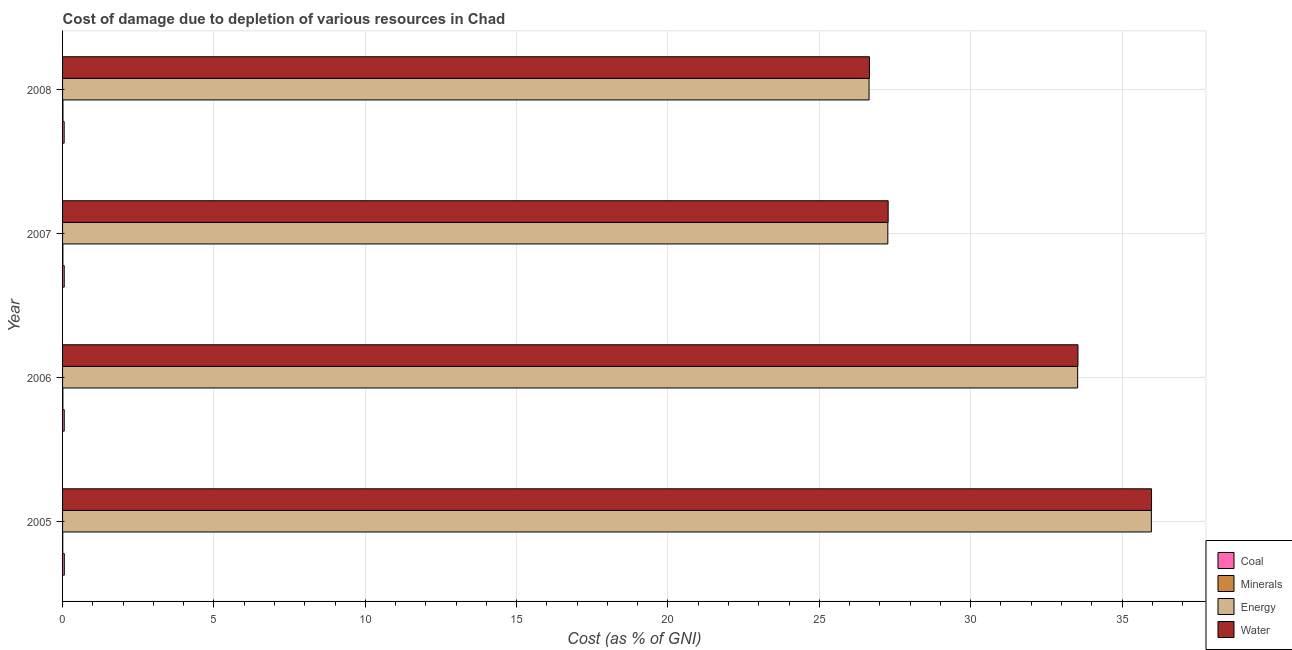Are the number of bars per tick equal to the number of legend labels?
Keep it short and to the point. Yes. Are the number of bars on each tick of the Y-axis equal?
Ensure brevity in your answer.  Yes. How many bars are there on the 1st tick from the top?
Provide a short and direct response. 4. How many bars are there on the 4th tick from the bottom?
Keep it short and to the point. 4. What is the label of the 1st group of bars from the top?
Give a very brief answer. 2008. In how many cases, is the number of bars for a given year not equal to the number of legend labels?
Your response must be concise. 0. What is the cost of damage due to depletion of energy in 2005?
Provide a short and direct response. 35.97. Across all years, what is the maximum cost of damage due to depletion of energy?
Ensure brevity in your answer.  35.97. Across all years, what is the minimum cost of damage due to depletion of energy?
Your response must be concise. 26.64. In which year was the cost of damage due to depletion of minerals maximum?
Offer a terse response. 2008. In which year was the cost of damage due to depletion of minerals minimum?
Make the answer very short. 2005. What is the total cost of damage due to depletion of coal in the graph?
Keep it short and to the point. 0.22. What is the difference between the cost of damage due to depletion of energy in 2006 and that in 2008?
Offer a very short reply. 6.89. What is the difference between the cost of damage due to depletion of minerals in 2008 and the cost of damage due to depletion of water in 2006?
Your answer should be very brief. -33.53. What is the average cost of damage due to depletion of coal per year?
Provide a succinct answer. 0.06. In the year 2005, what is the difference between the cost of damage due to depletion of energy and cost of damage due to depletion of minerals?
Offer a very short reply. 35.96. What is the ratio of the cost of damage due to depletion of coal in 2006 to that in 2007?
Offer a very short reply. 1.02. Is the difference between the cost of damage due to depletion of water in 2006 and 2008 greater than the difference between the cost of damage due to depletion of coal in 2006 and 2008?
Offer a very short reply. Yes. What is the difference between the highest and the second highest cost of damage due to depletion of minerals?
Ensure brevity in your answer.  0. What is the difference between the highest and the lowest cost of damage due to depletion of minerals?
Give a very brief answer. 0.01. In how many years, is the cost of damage due to depletion of coal greater than the average cost of damage due to depletion of coal taken over all years?
Offer a terse response. 2. What does the 2nd bar from the top in 2006 represents?
Your response must be concise. Energy. What does the 2nd bar from the bottom in 2006 represents?
Your answer should be compact. Minerals. Is it the case that in every year, the sum of the cost of damage due to depletion of coal and cost of damage due to depletion of minerals is greater than the cost of damage due to depletion of energy?
Make the answer very short. No. What is the difference between two consecutive major ticks on the X-axis?
Offer a terse response. 5. Does the graph contain any zero values?
Provide a short and direct response. No. Where does the legend appear in the graph?
Your answer should be compact. Bottom right. How are the legend labels stacked?
Your answer should be compact. Vertical. What is the title of the graph?
Your response must be concise. Cost of damage due to depletion of various resources in Chad . What is the label or title of the X-axis?
Ensure brevity in your answer.  Cost (as % of GNI). What is the Cost (as % of GNI) of Coal in 2005?
Provide a succinct answer. 0.06. What is the Cost (as % of GNI) in Minerals in 2005?
Provide a short and direct response. 0.01. What is the Cost (as % of GNI) of Energy in 2005?
Your response must be concise. 35.97. What is the Cost (as % of GNI) in Water in 2005?
Your response must be concise. 35.98. What is the Cost (as % of GNI) of Coal in 2006?
Give a very brief answer. 0.06. What is the Cost (as % of GNI) of Minerals in 2006?
Offer a terse response. 0.01. What is the Cost (as % of GNI) in Energy in 2006?
Give a very brief answer. 33.53. What is the Cost (as % of GNI) in Water in 2006?
Provide a succinct answer. 33.54. What is the Cost (as % of GNI) in Coal in 2007?
Offer a very short reply. 0.05. What is the Cost (as % of GNI) in Minerals in 2007?
Offer a terse response. 0.01. What is the Cost (as % of GNI) of Energy in 2007?
Your answer should be very brief. 27.26. What is the Cost (as % of GNI) of Water in 2007?
Your response must be concise. 27.27. What is the Cost (as % of GNI) in Coal in 2008?
Provide a succinct answer. 0.05. What is the Cost (as % of GNI) of Minerals in 2008?
Your answer should be compact. 0.01. What is the Cost (as % of GNI) of Energy in 2008?
Provide a short and direct response. 26.64. What is the Cost (as % of GNI) in Water in 2008?
Your answer should be very brief. 26.66. Across all years, what is the maximum Cost (as % of GNI) in Coal?
Offer a terse response. 0.06. Across all years, what is the maximum Cost (as % of GNI) in Minerals?
Provide a succinct answer. 0.01. Across all years, what is the maximum Cost (as % of GNI) in Energy?
Keep it short and to the point. 35.97. Across all years, what is the maximum Cost (as % of GNI) of Water?
Ensure brevity in your answer.  35.98. Across all years, what is the minimum Cost (as % of GNI) in Coal?
Provide a succinct answer. 0.05. Across all years, what is the minimum Cost (as % of GNI) of Minerals?
Give a very brief answer. 0.01. Across all years, what is the minimum Cost (as % of GNI) in Energy?
Keep it short and to the point. 26.64. Across all years, what is the minimum Cost (as % of GNI) of Water?
Offer a terse response. 26.66. What is the total Cost (as % of GNI) of Coal in the graph?
Offer a terse response. 0.22. What is the total Cost (as % of GNI) of Minerals in the graph?
Your answer should be very brief. 0.04. What is the total Cost (as % of GNI) in Energy in the graph?
Offer a terse response. 123.41. What is the total Cost (as % of GNI) in Water in the graph?
Keep it short and to the point. 123.45. What is the difference between the Cost (as % of GNI) of Coal in 2005 and that in 2006?
Make the answer very short. 0. What is the difference between the Cost (as % of GNI) in Minerals in 2005 and that in 2006?
Offer a very short reply. -0. What is the difference between the Cost (as % of GNI) of Energy in 2005 and that in 2006?
Your answer should be very brief. 2.43. What is the difference between the Cost (as % of GNI) in Water in 2005 and that in 2006?
Offer a very short reply. 2.43. What is the difference between the Cost (as % of GNI) of Coal in 2005 and that in 2007?
Ensure brevity in your answer.  0. What is the difference between the Cost (as % of GNI) in Minerals in 2005 and that in 2007?
Your answer should be very brief. -0.01. What is the difference between the Cost (as % of GNI) of Energy in 2005 and that in 2007?
Offer a very short reply. 8.71. What is the difference between the Cost (as % of GNI) in Water in 2005 and that in 2007?
Your answer should be compact. 8.7. What is the difference between the Cost (as % of GNI) in Coal in 2005 and that in 2008?
Give a very brief answer. 0. What is the difference between the Cost (as % of GNI) of Minerals in 2005 and that in 2008?
Offer a very short reply. -0.01. What is the difference between the Cost (as % of GNI) of Energy in 2005 and that in 2008?
Offer a terse response. 9.33. What is the difference between the Cost (as % of GNI) of Water in 2005 and that in 2008?
Offer a terse response. 9.32. What is the difference between the Cost (as % of GNI) of Coal in 2006 and that in 2007?
Your response must be concise. 0. What is the difference between the Cost (as % of GNI) in Minerals in 2006 and that in 2007?
Make the answer very short. -0. What is the difference between the Cost (as % of GNI) in Energy in 2006 and that in 2007?
Offer a terse response. 6.27. What is the difference between the Cost (as % of GNI) of Water in 2006 and that in 2007?
Ensure brevity in your answer.  6.27. What is the difference between the Cost (as % of GNI) of Coal in 2006 and that in 2008?
Make the answer very short. 0. What is the difference between the Cost (as % of GNI) of Minerals in 2006 and that in 2008?
Your response must be concise. -0. What is the difference between the Cost (as % of GNI) of Energy in 2006 and that in 2008?
Give a very brief answer. 6.89. What is the difference between the Cost (as % of GNI) of Water in 2006 and that in 2008?
Provide a succinct answer. 6.89. What is the difference between the Cost (as % of GNI) in Coal in 2007 and that in 2008?
Your answer should be very brief. 0. What is the difference between the Cost (as % of GNI) in Minerals in 2007 and that in 2008?
Offer a terse response. -0. What is the difference between the Cost (as % of GNI) of Energy in 2007 and that in 2008?
Your response must be concise. 0.62. What is the difference between the Cost (as % of GNI) of Water in 2007 and that in 2008?
Keep it short and to the point. 0.62. What is the difference between the Cost (as % of GNI) of Coal in 2005 and the Cost (as % of GNI) of Minerals in 2006?
Provide a succinct answer. 0.05. What is the difference between the Cost (as % of GNI) in Coal in 2005 and the Cost (as % of GNI) in Energy in 2006?
Offer a terse response. -33.48. What is the difference between the Cost (as % of GNI) in Coal in 2005 and the Cost (as % of GNI) in Water in 2006?
Provide a succinct answer. -33.49. What is the difference between the Cost (as % of GNI) of Minerals in 2005 and the Cost (as % of GNI) of Energy in 2006?
Give a very brief answer. -33.53. What is the difference between the Cost (as % of GNI) of Minerals in 2005 and the Cost (as % of GNI) of Water in 2006?
Give a very brief answer. -33.54. What is the difference between the Cost (as % of GNI) of Energy in 2005 and the Cost (as % of GNI) of Water in 2006?
Your answer should be very brief. 2.42. What is the difference between the Cost (as % of GNI) in Coal in 2005 and the Cost (as % of GNI) in Minerals in 2007?
Offer a terse response. 0.05. What is the difference between the Cost (as % of GNI) in Coal in 2005 and the Cost (as % of GNI) in Energy in 2007?
Provide a succinct answer. -27.21. What is the difference between the Cost (as % of GNI) in Coal in 2005 and the Cost (as % of GNI) in Water in 2007?
Your answer should be very brief. -27.22. What is the difference between the Cost (as % of GNI) of Minerals in 2005 and the Cost (as % of GNI) of Energy in 2007?
Offer a very short reply. -27.26. What is the difference between the Cost (as % of GNI) of Minerals in 2005 and the Cost (as % of GNI) of Water in 2007?
Provide a succinct answer. -27.27. What is the difference between the Cost (as % of GNI) of Energy in 2005 and the Cost (as % of GNI) of Water in 2007?
Your response must be concise. 8.7. What is the difference between the Cost (as % of GNI) of Coal in 2005 and the Cost (as % of GNI) of Minerals in 2008?
Offer a terse response. 0.04. What is the difference between the Cost (as % of GNI) in Coal in 2005 and the Cost (as % of GNI) in Energy in 2008?
Provide a succinct answer. -26.59. What is the difference between the Cost (as % of GNI) of Coal in 2005 and the Cost (as % of GNI) of Water in 2008?
Your answer should be very brief. -26.6. What is the difference between the Cost (as % of GNI) in Minerals in 2005 and the Cost (as % of GNI) in Energy in 2008?
Ensure brevity in your answer.  -26.64. What is the difference between the Cost (as % of GNI) of Minerals in 2005 and the Cost (as % of GNI) of Water in 2008?
Make the answer very short. -26.65. What is the difference between the Cost (as % of GNI) of Energy in 2005 and the Cost (as % of GNI) of Water in 2008?
Offer a very short reply. 9.31. What is the difference between the Cost (as % of GNI) of Coal in 2006 and the Cost (as % of GNI) of Minerals in 2007?
Offer a very short reply. 0.04. What is the difference between the Cost (as % of GNI) in Coal in 2006 and the Cost (as % of GNI) in Energy in 2007?
Offer a very short reply. -27.21. What is the difference between the Cost (as % of GNI) of Coal in 2006 and the Cost (as % of GNI) of Water in 2007?
Provide a short and direct response. -27.22. What is the difference between the Cost (as % of GNI) of Minerals in 2006 and the Cost (as % of GNI) of Energy in 2007?
Make the answer very short. -27.25. What is the difference between the Cost (as % of GNI) of Minerals in 2006 and the Cost (as % of GNI) of Water in 2007?
Offer a terse response. -27.26. What is the difference between the Cost (as % of GNI) of Energy in 2006 and the Cost (as % of GNI) of Water in 2007?
Provide a short and direct response. 6.26. What is the difference between the Cost (as % of GNI) in Coal in 2006 and the Cost (as % of GNI) in Minerals in 2008?
Provide a succinct answer. 0.04. What is the difference between the Cost (as % of GNI) of Coal in 2006 and the Cost (as % of GNI) of Energy in 2008?
Offer a very short reply. -26.59. What is the difference between the Cost (as % of GNI) of Coal in 2006 and the Cost (as % of GNI) of Water in 2008?
Offer a terse response. -26.6. What is the difference between the Cost (as % of GNI) of Minerals in 2006 and the Cost (as % of GNI) of Energy in 2008?
Provide a short and direct response. -26.63. What is the difference between the Cost (as % of GNI) of Minerals in 2006 and the Cost (as % of GNI) of Water in 2008?
Your answer should be very brief. -26.65. What is the difference between the Cost (as % of GNI) in Energy in 2006 and the Cost (as % of GNI) in Water in 2008?
Your answer should be compact. 6.88. What is the difference between the Cost (as % of GNI) in Coal in 2007 and the Cost (as % of GNI) in Minerals in 2008?
Offer a terse response. 0.04. What is the difference between the Cost (as % of GNI) in Coal in 2007 and the Cost (as % of GNI) in Energy in 2008?
Your response must be concise. -26.59. What is the difference between the Cost (as % of GNI) in Coal in 2007 and the Cost (as % of GNI) in Water in 2008?
Your answer should be very brief. -26.6. What is the difference between the Cost (as % of GNI) of Minerals in 2007 and the Cost (as % of GNI) of Energy in 2008?
Offer a terse response. -26.63. What is the difference between the Cost (as % of GNI) in Minerals in 2007 and the Cost (as % of GNI) in Water in 2008?
Your response must be concise. -26.65. What is the difference between the Cost (as % of GNI) in Energy in 2007 and the Cost (as % of GNI) in Water in 2008?
Ensure brevity in your answer.  0.61. What is the average Cost (as % of GNI) in Coal per year?
Your response must be concise. 0.06. What is the average Cost (as % of GNI) in Minerals per year?
Make the answer very short. 0.01. What is the average Cost (as % of GNI) in Energy per year?
Your answer should be very brief. 30.85. What is the average Cost (as % of GNI) in Water per year?
Ensure brevity in your answer.  30.86. In the year 2005, what is the difference between the Cost (as % of GNI) in Coal and Cost (as % of GNI) in Minerals?
Offer a terse response. 0.05. In the year 2005, what is the difference between the Cost (as % of GNI) of Coal and Cost (as % of GNI) of Energy?
Keep it short and to the point. -35.91. In the year 2005, what is the difference between the Cost (as % of GNI) of Coal and Cost (as % of GNI) of Water?
Your response must be concise. -35.92. In the year 2005, what is the difference between the Cost (as % of GNI) of Minerals and Cost (as % of GNI) of Energy?
Provide a short and direct response. -35.96. In the year 2005, what is the difference between the Cost (as % of GNI) of Minerals and Cost (as % of GNI) of Water?
Make the answer very short. -35.97. In the year 2005, what is the difference between the Cost (as % of GNI) in Energy and Cost (as % of GNI) in Water?
Make the answer very short. -0.01. In the year 2006, what is the difference between the Cost (as % of GNI) in Coal and Cost (as % of GNI) in Minerals?
Your answer should be compact. 0.05. In the year 2006, what is the difference between the Cost (as % of GNI) in Coal and Cost (as % of GNI) in Energy?
Keep it short and to the point. -33.48. In the year 2006, what is the difference between the Cost (as % of GNI) in Coal and Cost (as % of GNI) in Water?
Ensure brevity in your answer.  -33.49. In the year 2006, what is the difference between the Cost (as % of GNI) of Minerals and Cost (as % of GNI) of Energy?
Your response must be concise. -33.52. In the year 2006, what is the difference between the Cost (as % of GNI) of Minerals and Cost (as % of GNI) of Water?
Offer a terse response. -33.53. In the year 2006, what is the difference between the Cost (as % of GNI) of Energy and Cost (as % of GNI) of Water?
Ensure brevity in your answer.  -0.01. In the year 2007, what is the difference between the Cost (as % of GNI) of Coal and Cost (as % of GNI) of Minerals?
Your response must be concise. 0.04. In the year 2007, what is the difference between the Cost (as % of GNI) of Coal and Cost (as % of GNI) of Energy?
Your answer should be compact. -27.21. In the year 2007, what is the difference between the Cost (as % of GNI) in Coal and Cost (as % of GNI) in Water?
Offer a terse response. -27.22. In the year 2007, what is the difference between the Cost (as % of GNI) of Minerals and Cost (as % of GNI) of Energy?
Offer a very short reply. -27.25. In the year 2007, what is the difference between the Cost (as % of GNI) in Minerals and Cost (as % of GNI) in Water?
Your response must be concise. -27.26. In the year 2007, what is the difference between the Cost (as % of GNI) in Energy and Cost (as % of GNI) in Water?
Provide a succinct answer. -0.01. In the year 2008, what is the difference between the Cost (as % of GNI) of Coal and Cost (as % of GNI) of Minerals?
Ensure brevity in your answer.  0.04. In the year 2008, what is the difference between the Cost (as % of GNI) in Coal and Cost (as % of GNI) in Energy?
Provide a succinct answer. -26.59. In the year 2008, what is the difference between the Cost (as % of GNI) in Coal and Cost (as % of GNI) in Water?
Your answer should be compact. -26.6. In the year 2008, what is the difference between the Cost (as % of GNI) of Minerals and Cost (as % of GNI) of Energy?
Make the answer very short. -26.63. In the year 2008, what is the difference between the Cost (as % of GNI) of Minerals and Cost (as % of GNI) of Water?
Provide a short and direct response. -26.64. In the year 2008, what is the difference between the Cost (as % of GNI) in Energy and Cost (as % of GNI) in Water?
Make the answer very short. -0.01. What is the ratio of the Cost (as % of GNI) in Coal in 2005 to that in 2006?
Provide a succinct answer. 1.04. What is the ratio of the Cost (as % of GNI) in Minerals in 2005 to that in 2006?
Give a very brief answer. 0.53. What is the ratio of the Cost (as % of GNI) of Energy in 2005 to that in 2006?
Give a very brief answer. 1.07. What is the ratio of the Cost (as % of GNI) in Water in 2005 to that in 2006?
Your answer should be very brief. 1.07. What is the ratio of the Cost (as % of GNI) of Coal in 2005 to that in 2007?
Your response must be concise. 1.06. What is the ratio of the Cost (as % of GNI) in Minerals in 2005 to that in 2007?
Your answer should be compact. 0.51. What is the ratio of the Cost (as % of GNI) of Energy in 2005 to that in 2007?
Offer a terse response. 1.32. What is the ratio of the Cost (as % of GNI) in Water in 2005 to that in 2007?
Ensure brevity in your answer.  1.32. What is the ratio of the Cost (as % of GNI) in Coal in 2005 to that in 2008?
Offer a very short reply. 1.09. What is the ratio of the Cost (as % of GNI) of Minerals in 2005 to that in 2008?
Offer a very short reply. 0.42. What is the ratio of the Cost (as % of GNI) of Energy in 2005 to that in 2008?
Your answer should be compact. 1.35. What is the ratio of the Cost (as % of GNI) of Water in 2005 to that in 2008?
Provide a succinct answer. 1.35. What is the ratio of the Cost (as % of GNI) in Coal in 2006 to that in 2007?
Your response must be concise. 1.02. What is the ratio of the Cost (as % of GNI) in Minerals in 2006 to that in 2007?
Offer a terse response. 0.96. What is the ratio of the Cost (as % of GNI) of Energy in 2006 to that in 2007?
Keep it short and to the point. 1.23. What is the ratio of the Cost (as % of GNI) of Water in 2006 to that in 2007?
Make the answer very short. 1.23. What is the ratio of the Cost (as % of GNI) in Coal in 2006 to that in 2008?
Make the answer very short. 1.05. What is the ratio of the Cost (as % of GNI) of Minerals in 2006 to that in 2008?
Make the answer very short. 0.79. What is the ratio of the Cost (as % of GNI) of Energy in 2006 to that in 2008?
Keep it short and to the point. 1.26. What is the ratio of the Cost (as % of GNI) in Water in 2006 to that in 2008?
Ensure brevity in your answer.  1.26. What is the ratio of the Cost (as % of GNI) of Coal in 2007 to that in 2008?
Keep it short and to the point. 1.03. What is the ratio of the Cost (as % of GNI) in Minerals in 2007 to that in 2008?
Make the answer very short. 0.83. What is the ratio of the Cost (as % of GNI) of Energy in 2007 to that in 2008?
Provide a succinct answer. 1.02. What is the ratio of the Cost (as % of GNI) of Water in 2007 to that in 2008?
Give a very brief answer. 1.02. What is the difference between the highest and the second highest Cost (as % of GNI) in Coal?
Offer a terse response. 0. What is the difference between the highest and the second highest Cost (as % of GNI) in Minerals?
Your answer should be very brief. 0. What is the difference between the highest and the second highest Cost (as % of GNI) in Energy?
Give a very brief answer. 2.43. What is the difference between the highest and the second highest Cost (as % of GNI) of Water?
Ensure brevity in your answer.  2.43. What is the difference between the highest and the lowest Cost (as % of GNI) of Coal?
Keep it short and to the point. 0. What is the difference between the highest and the lowest Cost (as % of GNI) in Minerals?
Ensure brevity in your answer.  0.01. What is the difference between the highest and the lowest Cost (as % of GNI) in Energy?
Your response must be concise. 9.33. What is the difference between the highest and the lowest Cost (as % of GNI) in Water?
Your answer should be very brief. 9.32. 